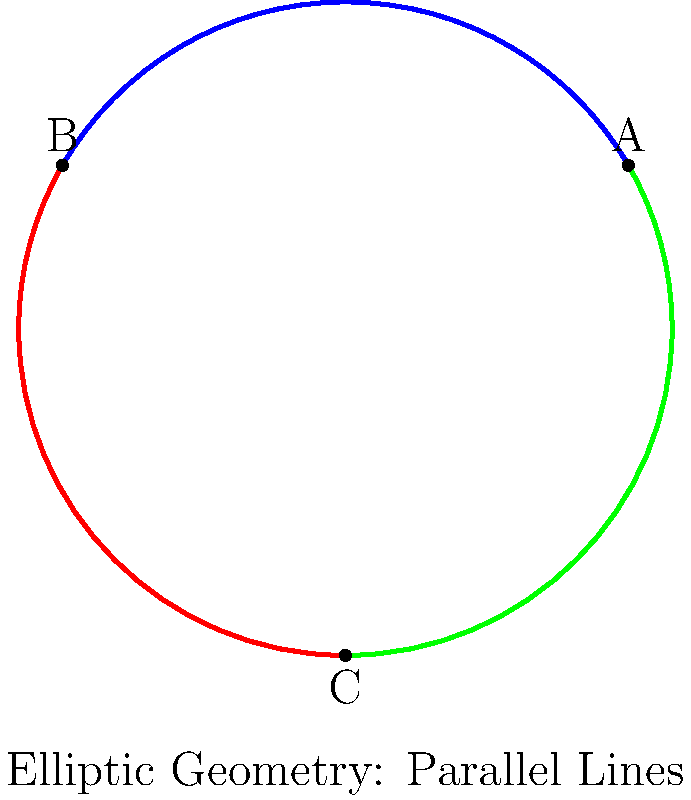In the picture, we see a circle with three coloured lines. These lines represent "parallel" lines in elliptic geometry. How many times do these "parallel" lines meet? To understand this, let's follow these steps:

1. In regular (Euclidean) geometry, parallel lines never meet. But this picture shows elliptic geometry, which is different.

2. In elliptic geometry, we imagine the surface of a sphere instead of a flat plane.

3. The circle in the picture represents the whole sphere, seen from above.

4. The coloured lines (blue, red, and green) are actually great circles on this sphere. Great circles are the largest circles you can draw on a sphere's surface.

5. In elliptic geometry, these great circles are considered "parallel" lines.

6. We can see that each coloured line meets the other two lines at two points:
   - Blue meets Red at point B
   - Red meets Green at point C
   - Green meets Blue at point A

7. Counting these meeting points, we find that each "parallel" line meets the others twice.

Therefore, these three "parallel" lines in elliptic geometry meet a total of 6 times (2 times for each pair of lines).
Answer: 6 times 